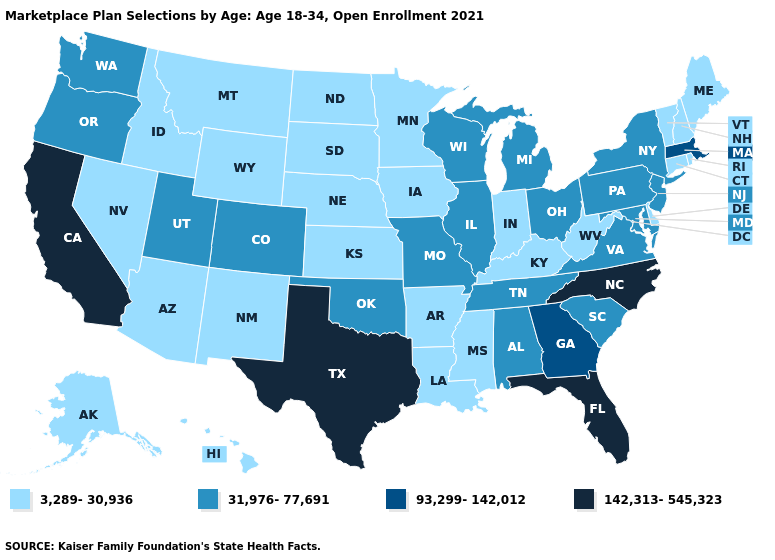Among the states that border Pennsylvania , which have the highest value?
Quick response, please. Maryland, New Jersey, New York, Ohio. Name the states that have a value in the range 93,299-142,012?
Write a very short answer. Georgia, Massachusetts. Among the states that border Oregon , does California have the highest value?
Quick response, please. Yes. Name the states that have a value in the range 3,289-30,936?
Answer briefly. Alaska, Arizona, Arkansas, Connecticut, Delaware, Hawaii, Idaho, Indiana, Iowa, Kansas, Kentucky, Louisiana, Maine, Minnesota, Mississippi, Montana, Nebraska, Nevada, New Hampshire, New Mexico, North Dakota, Rhode Island, South Dakota, Vermont, West Virginia, Wyoming. Which states have the highest value in the USA?
Short answer required. California, Florida, North Carolina, Texas. Does the first symbol in the legend represent the smallest category?
Quick response, please. Yes. What is the value of Minnesota?
Write a very short answer. 3,289-30,936. What is the value of Colorado?
Keep it brief. 31,976-77,691. Name the states that have a value in the range 93,299-142,012?
Be succinct. Georgia, Massachusetts. How many symbols are there in the legend?
Keep it brief. 4. Among the states that border Wyoming , does Colorado have the lowest value?
Keep it brief. No. How many symbols are there in the legend?
Give a very brief answer. 4. Which states hav the highest value in the West?
Quick response, please. California. Among the states that border Indiana , which have the lowest value?
Write a very short answer. Kentucky. Which states have the lowest value in the USA?
Quick response, please. Alaska, Arizona, Arkansas, Connecticut, Delaware, Hawaii, Idaho, Indiana, Iowa, Kansas, Kentucky, Louisiana, Maine, Minnesota, Mississippi, Montana, Nebraska, Nevada, New Hampshire, New Mexico, North Dakota, Rhode Island, South Dakota, Vermont, West Virginia, Wyoming. 